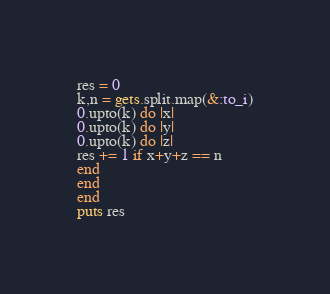<code> <loc_0><loc_0><loc_500><loc_500><_Ruby_>res = 0
k,n = gets.split.map(&:to_i)
0.upto(k) do |x|
0.upto(k) do |y|
0.upto(k) do |z|
res += 1 if x+y+z == n
end
end
end
puts res</code> 